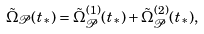<formula> <loc_0><loc_0><loc_500><loc_500>\tilde { \Omega } _ { \mathcal { P } } ( t _ { * } ) = \tilde { \Omega } ^ { ( 1 ) } _ { \mathcal { P } } ( t _ { * } ) + \tilde { \Omega } ^ { ( 2 ) } _ { \mathcal { P } } ( t _ { * } ) ,</formula> 